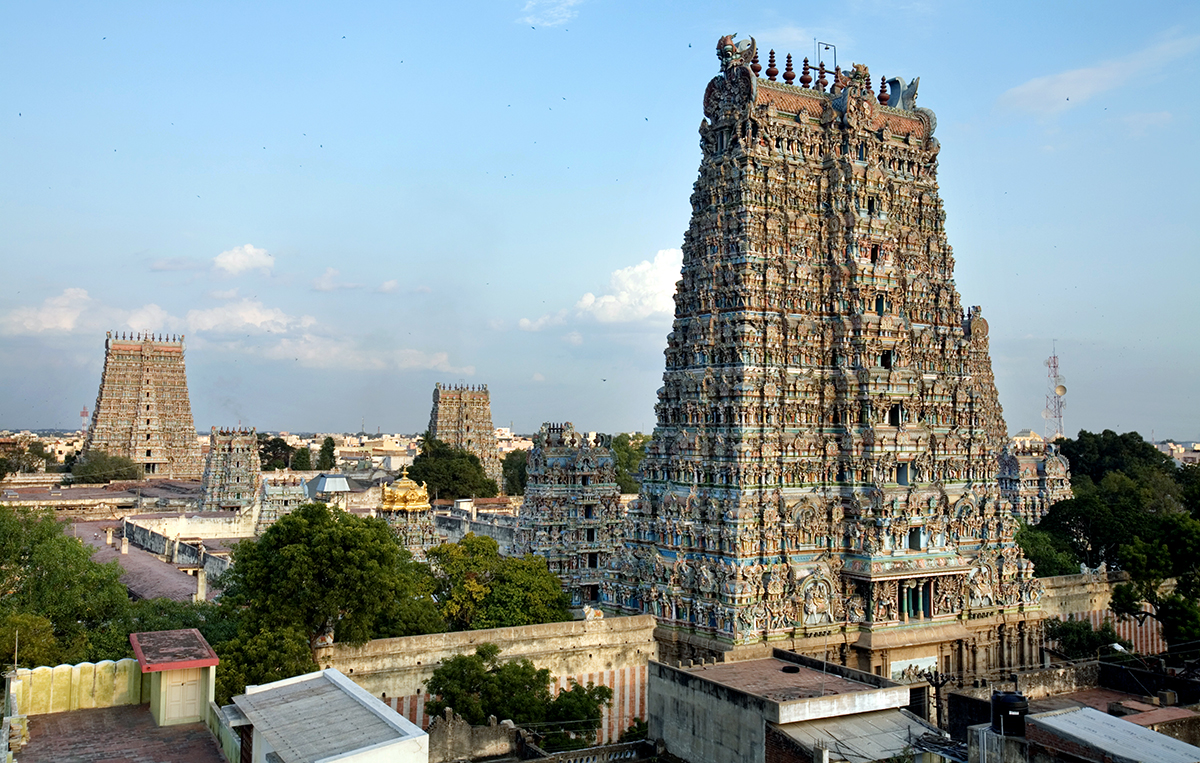Can you elaborate on the elements of the picture provided?
 The image captures the grandeur of the Meenakshi Amman Temple, a significant landmark in India. The temple, known for its vibrant and intricate architecture, stands majestically amidst the cityscape of Madurai. 

The temple's multiple towers, or gopurams, rise into the sky, each adorned with a riot of colorful sculptures and carvings depicting Hindu deities and mythological figures. These detailed artworks lend a sense of divine aura to the temple, making it a visual spectacle.

Surrounding the temple, you can see a mix of traditional and modern structures. A smaller temple tower echoes the grandeur of the main temple, while a telecommunications tower in the background signifies the blend of tradition and modernity in the city.

The image is taken from a high vantage point, offering a bird's eye view of the temple and its surroundings. This perspective not only highlights the scale and intricacy of the temple but also provides a glimpse into the urban landscape of Madurai. The temple, with its vibrant colors and intricate details, stands out as a beacon of cultural heritage amidst the city's modern infrastructure. 